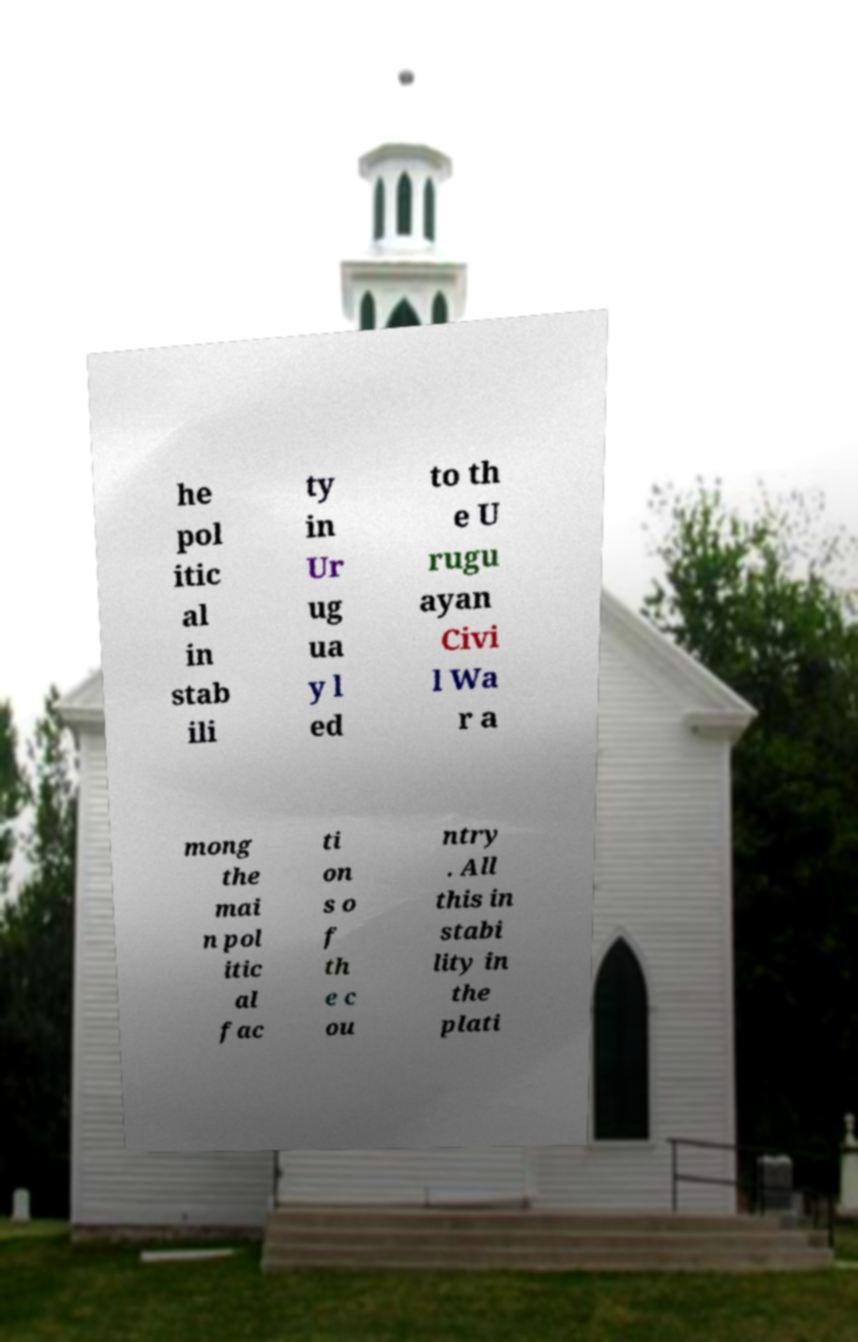What messages or text are displayed in this image? I need them in a readable, typed format. he pol itic al in stab ili ty in Ur ug ua y l ed to th e U rugu ayan Civi l Wa r a mong the mai n pol itic al fac ti on s o f th e c ou ntry . All this in stabi lity in the plati 